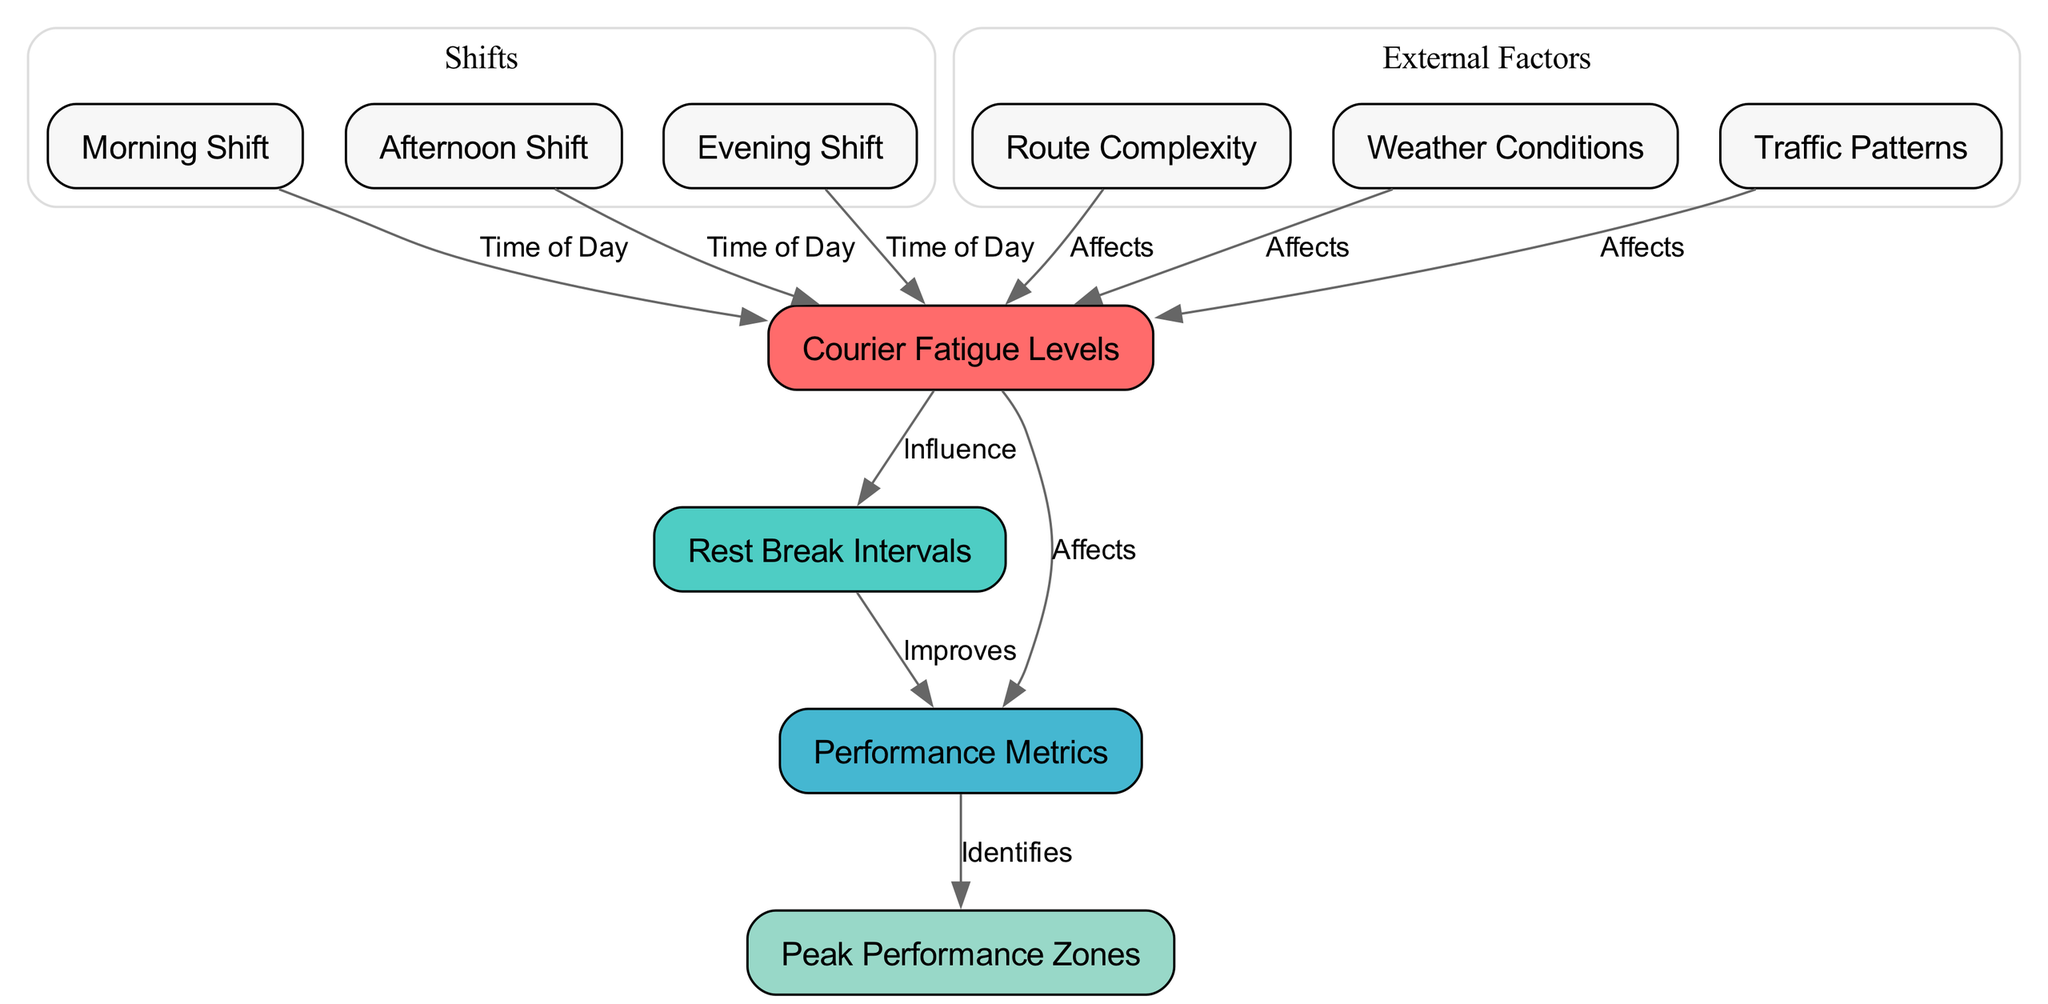What are the three shifts represented in the diagram? The diagram has nodes labeled "Morning Shift," "Afternoon Shift," and "Evening Shift," which are indicated by IDs 3, 4, and 5, respectively.
Answer: Morning Shift, Afternoon Shift, Evening Shift How many nodes are there in total? The diagram contains a total of 10 nodes including "Courier Fatigue Levels," "Rest Break Intervals," "Performance Metrics," and others, as listed.
Answer: 10 Which node does "Rest Break Intervals" influence? The edge from "Rest Break Intervals" to "Performance Metrics" indicates that "Rest Break Intervals" improves "Performance Metrics."
Answer: Performance Metrics What external factors affect courier fatigue levels? The diagram shows edges from "Route Complexity," "Weather Conditions," and "Traffic Patterns" to "Courier Fatigue Levels," indicating they all affect fatigue levels.
Answer: Route Complexity, Weather Conditions, Traffic Patterns How does the time of day relate to courier fatigue levels? The edges from "Morning Shift," "Afternoon Shift," and "Evening Shift" to "Courier Fatigue Levels" indicate that the time of day impacts fatigue levels during these shifts.
Answer: Time of Day Which node identifies peak performance zones? The diagram shows that "Performance Metrics" identifies "Peak Performance Zones," indicated by an edge from "Performance Metrics" to "Peak Performance Zones."
Answer: Peak Performance Zones What is the relationship between courier fatigue levels and rest break intervals? The edge from "Courier Fatigue Levels" to "Rest Break Intervals" indicates that fatigue levels influence the need for rest breaks.
Answer: Influence Do rest break intervals improve performance metrics? Yes, the edge labeled "Improves" from "Rest Break Intervals" to "Performance Metrics" confirms that rest breaks improve performance metrics.
Answer: Yes 